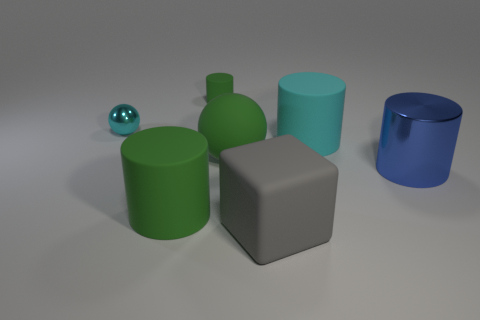Add 3 tiny purple matte blocks. How many objects exist? 10 Subtract all blue cylinders. How many cylinders are left? 3 Subtract all green balls. How many balls are left? 1 Subtract all cylinders. How many objects are left? 3 Subtract all blue cylinders. How many cyan spheres are left? 1 Subtract all big blue shiny things. Subtract all small cylinders. How many objects are left? 5 Add 1 large gray cubes. How many large gray cubes are left? 2 Add 4 large cyan blocks. How many large cyan blocks exist? 4 Subtract 1 cyan cylinders. How many objects are left? 6 Subtract 4 cylinders. How many cylinders are left? 0 